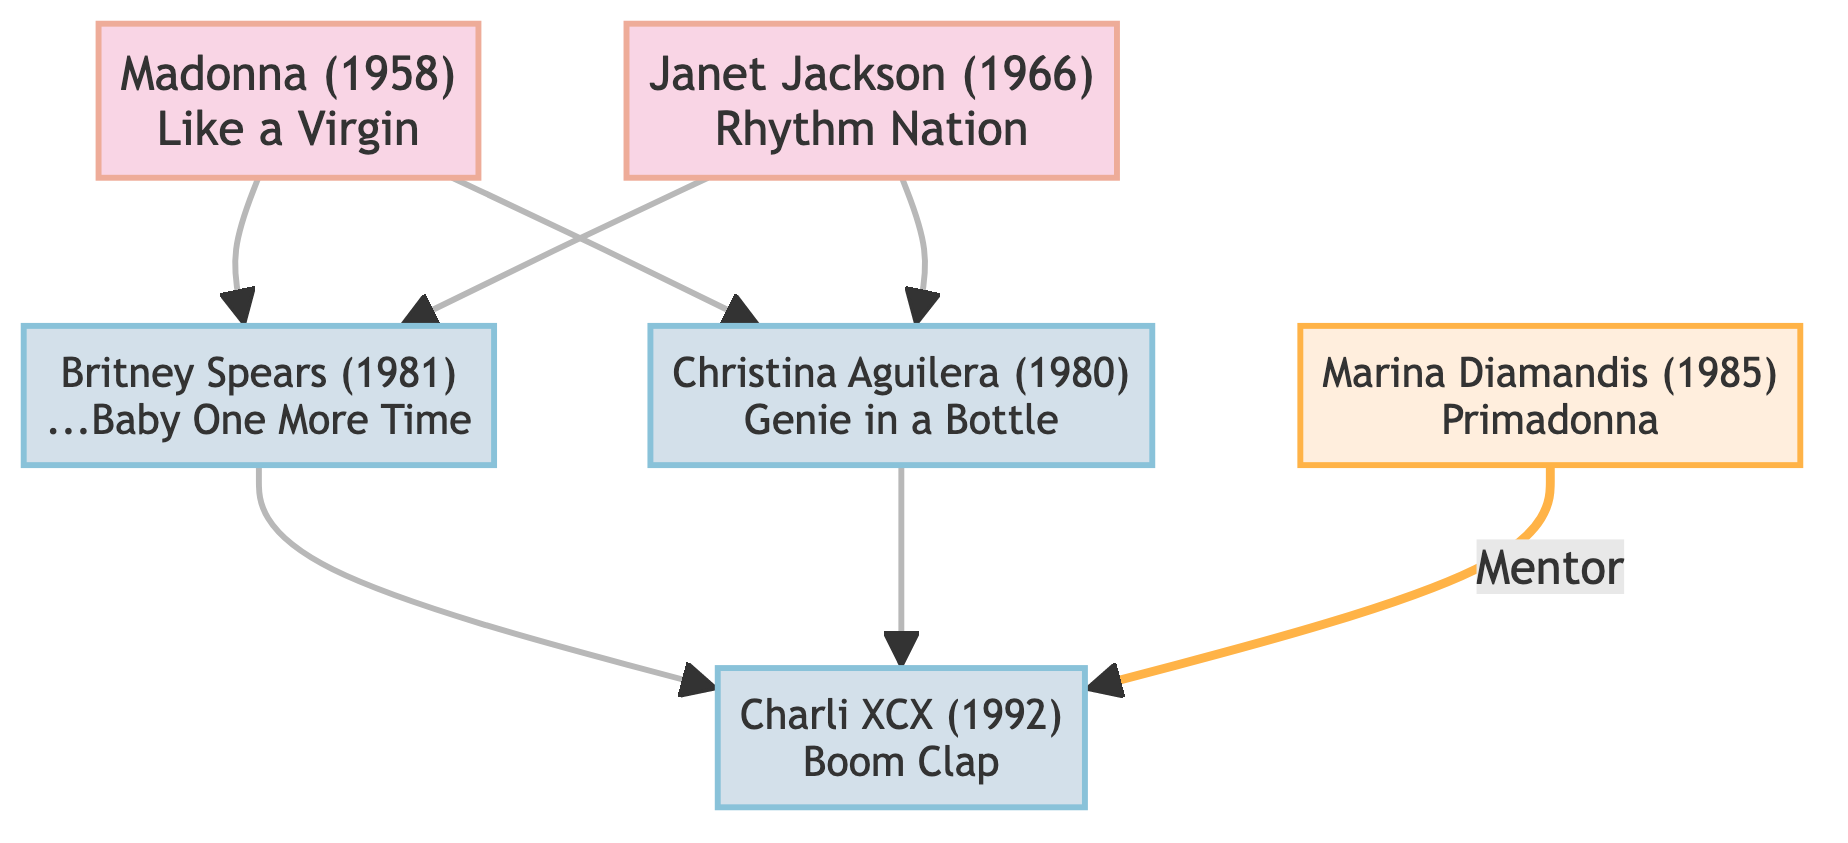What is Charli XCX's real name? The diagram indicates that Charli XCX is actually named Charlotte Emma Aitchison. This information is typically shown along with the node for Charli XCX in the diagram.
Answer: Charlotte Emma Aitchison Who mentored Charli XCX? The flowchart shows a connection labeled "Mentor" from Marina Diamandis to Charli XCX, indicating that Marina Diamandis played a mentoring role in Charli XCX's career.
Answer: Marina Diamandis How many major hits are listed for Christina Aguilera? The diagram lists one major hit for Christina Aguilera, which is "Genie in a Bottle." Therefore, the count of major hits shown in the diagram for her is one.
Answer: 1 Which iconic pop star was influenced by both Madonna and Britney Spears? To answer, we can trace the arrows from the nodes. The diagram shows that Charli XCX was influenced by both Britney Spears and Madonna, indicating that she is the pop star in question.
Answer: Charli XCX What year was Janet Jackson born? The diagram provides the birth year next to Janet Jackson’s name, which states that she was born in 1966.
Answer: 1966 Which two artists connect Madonna to Britney Spears? Following the diagram, Madonna influences both Britney Spears and Christina Aguilera. Thus, the artists connecting these two nodes are Madonna and Christina Aguilera.
Answer: Madonna and Christina Aguilera How many artists did Janet Jackson influence? The diagram indicates that Janet Jackson influenced two artists: Britney Spears and Beyoncé. Therefore the count of artists that Janet influences is two.
Answer: 2 What major hit connects Marina to Charli XCX? From the diagram, Marina is connected to Charli XCX with the label "Mentor," which implies that Marina has helped the career of Charli, but there is no major hit in this specific connection. Thus, there is no major hit connecting them directly.
Answer: None Which artist is known for "Boom Clap"? The diagram states that Charli XCX is associated with the major hit "Boom Clap." This can be found prominently next to her name in the flowchart.
Answer: Charli XCX 